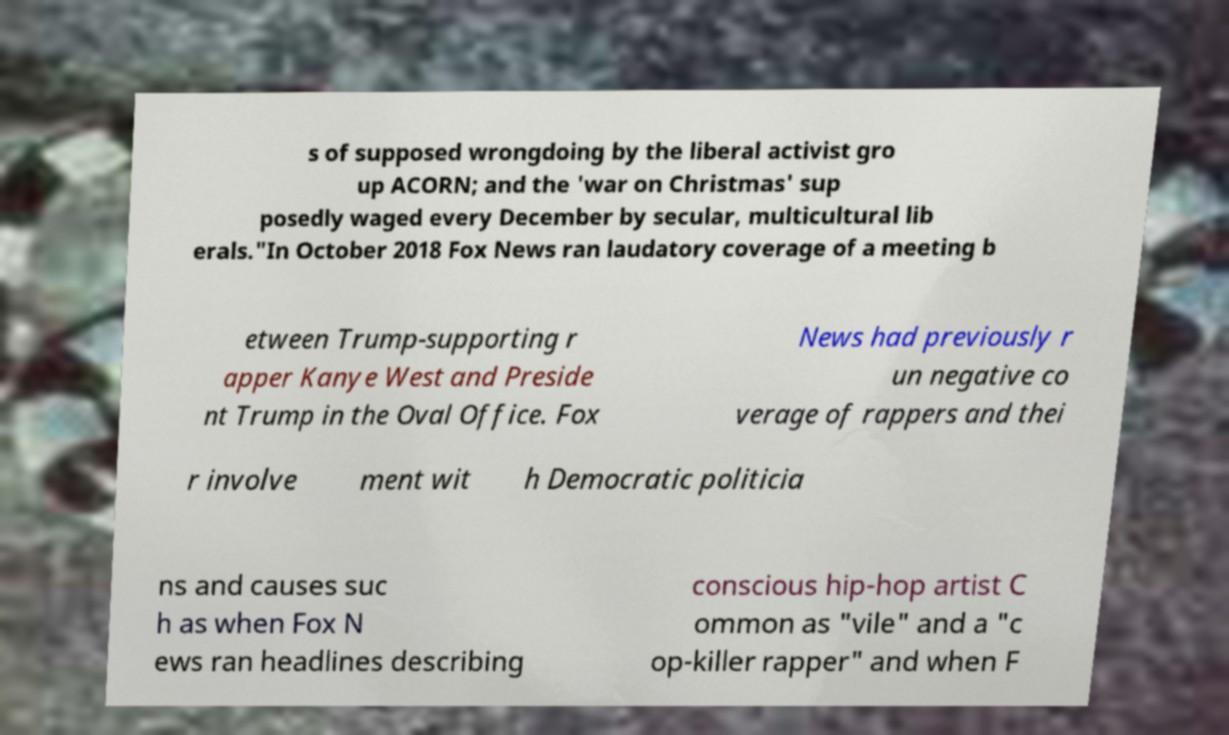Could you assist in decoding the text presented in this image and type it out clearly? s of supposed wrongdoing by the liberal activist gro up ACORN; and the 'war on Christmas' sup posedly waged every December by secular, multicultural lib erals."In October 2018 Fox News ran laudatory coverage of a meeting b etween Trump-supporting r apper Kanye West and Preside nt Trump in the Oval Office. Fox News had previously r un negative co verage of rappers and thei r involve ment wit h Democratic politicia ns and causes suc h as when Fox N ews ran headlines describing conscious hip-hop artist C ommon as "vile" and a "c op-killer rapper" and when F 